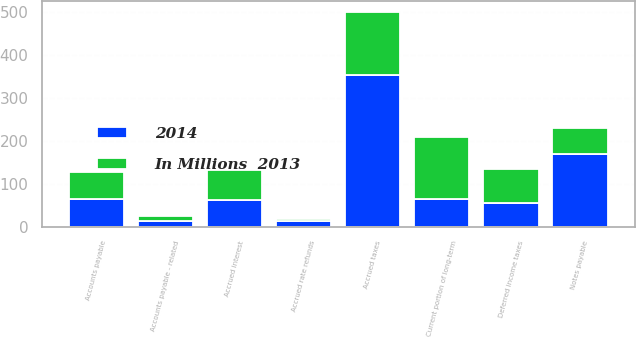Convert chart to OTSL. <chart><loc_0><loc_0><loc_500><loc_500><stacked_bar_chart><ecel><fcel>Current portion of long-term<fcel>Notes payable<fcel>Accounts payable<fcel>Accounts payable - related<fcel>Accrued rate refunds<fcel>Accrued interest<fcel>Accrued taxes<fcel>Deferred income taxes<nl><fcel>In Millions  2013<fcel>145<fcel>60<fcel>63.5<fcel>12<fcel>6<fcel>70<fcel>149<fcel>80<nl><fcel>2014<fcel>64<fcel>170<fcel>63.5<fcel>13<fcel>12<fcel>63<fcel>353<fcel>55<nl></chart> 